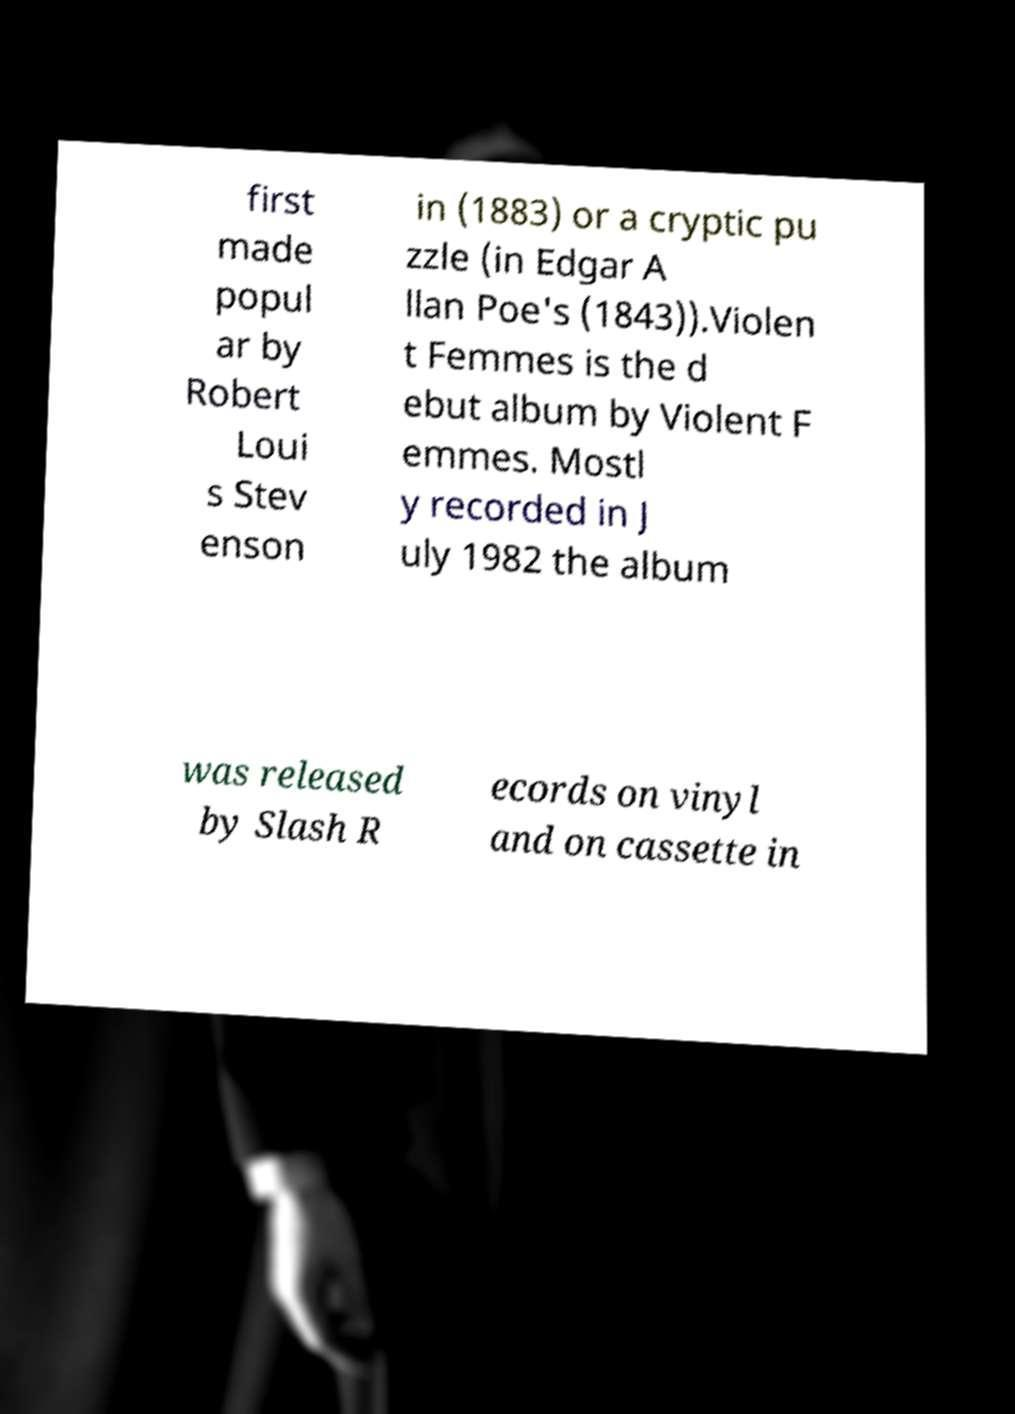There's text embedded in this image that I need extracted. Can you transcribe it verbatim? first made popul ar by Robert Loui s Stev enson in (1883) or a cryptic pu zzle (in Edgar A llan Poe's (1843)).Violen t Femmes is the d ebut album by Violent F emmes. Mostl y recorded in J uly 1982 the album was released by Slash R ecords on vinyl and on cassette in 